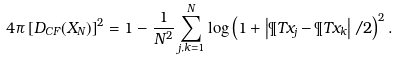<formula> <loc_0><loc_0><loc_500><loc_500>4 \pi \left [ D _ { C F } ( X _ { N } ) \right ] ^ { 2 } = 1 - \frac { 1 } { N ^ { 2 } } \sum _ { j , k = 1 } ^ { N } \log \left ( 1 + \left | \P T { x } _ { j } - \P T { x } _ { k } \right | / 2 \right ) ^ { 2 } .</formula> 